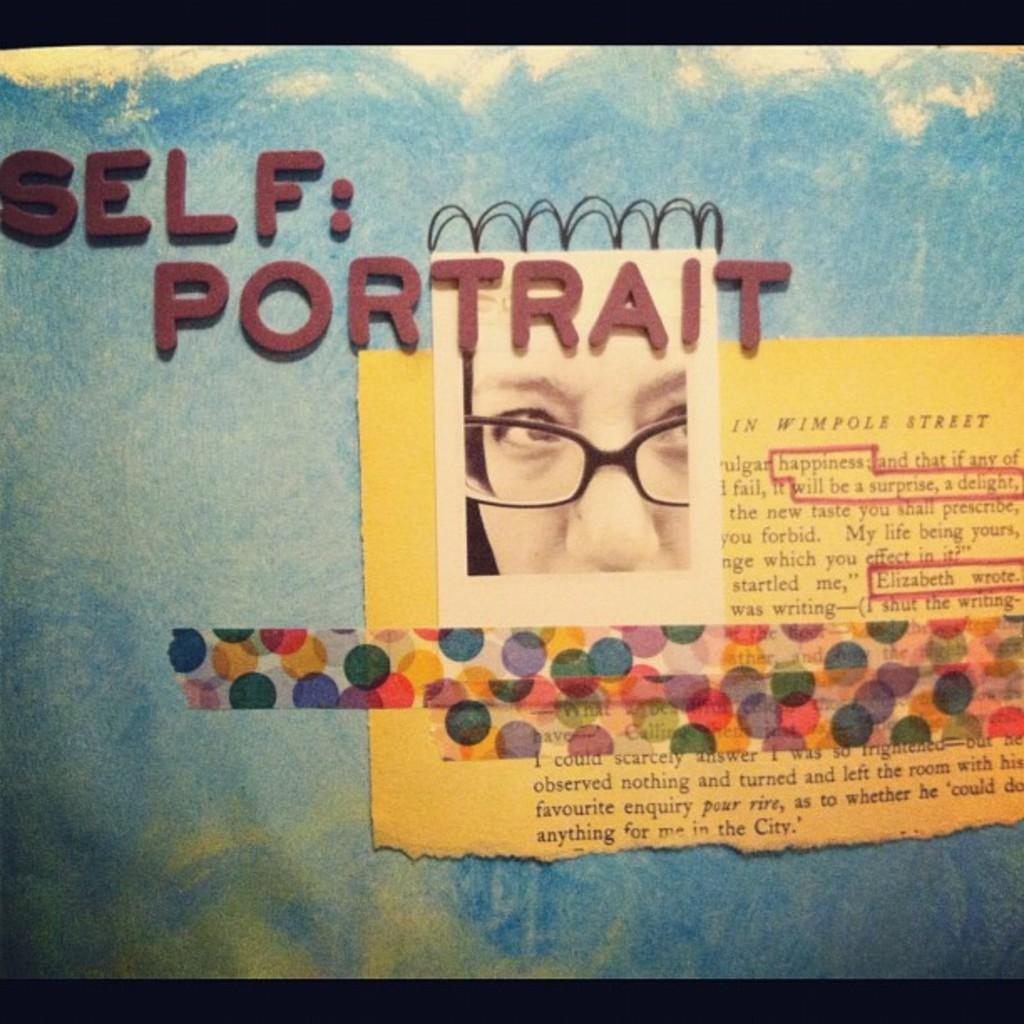What is written on the sheet of paper in the image? The facts do not specify the content of the text on the sheet of paper. What can be seen in the photo within the image? There is a photo of a person in the image. What color is the background of the image? The background of the image is blue. What type of good-bye is being expressed in the photo within the image? There is no indication of a good-bye or any emotions being expressed in the photo within the image. What caused the burst in the image? There is no burst or any indication of damage in the image. 